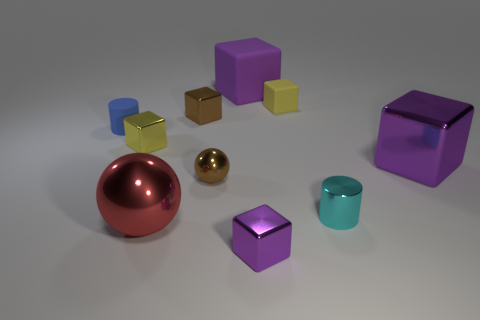Subtract all purple shiny blocks. How many blocks are left? 4 Subtract all cyan cylinders. How many cylinders are left? 1 Subtract all balls. How many objects are left? 8 Add 4 brown shiny objects. How many brown shiny objects are left? 6 Add 2 big shiny spheres. How many big shiny spheres exist? 3 Subtract 3 purple blocks. How many objects are left? 7 Subtract 1 cylinders. How many cylinders are left? 1 Subtract all blue spheres. Subtract all yellow cubes. How many spheres are left? 2 Subtract all green cylinders. How many red balls are left? 1 Subtract all small objects. Subtract all large rubber objects. How many objects are left? 2 